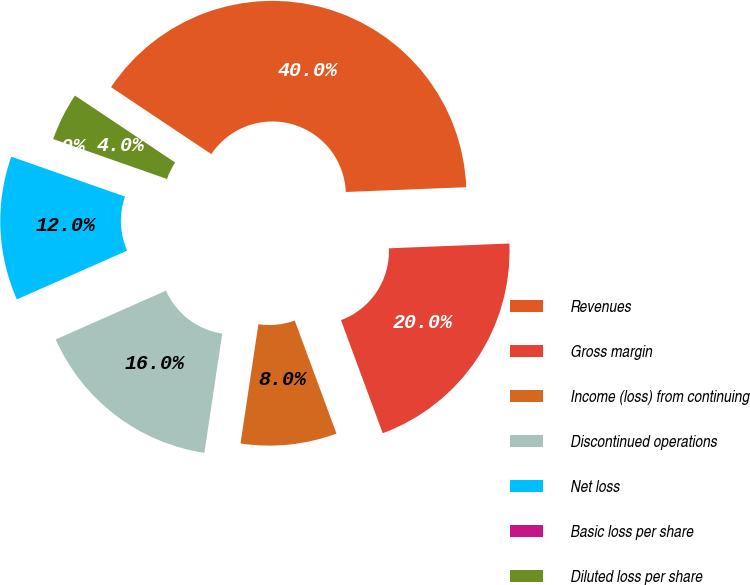<chart> <loc_0><loc_0><loc_500><loc_500><pie_chart><fcel>Revenues<fcel>Gross margin<fcel>Income (loss) from continuing<fcel>Discontinued operations<fcel>Net loss<fcel>Basic loss per share<fcel>Diluted loss per share<nl><fcel>39.99%<fcel>20.0%<fcel>8.0%<fcel>16.0%<fcel>12.0%<fcel>0.0%<fcel>4.0%<nl></chart> 